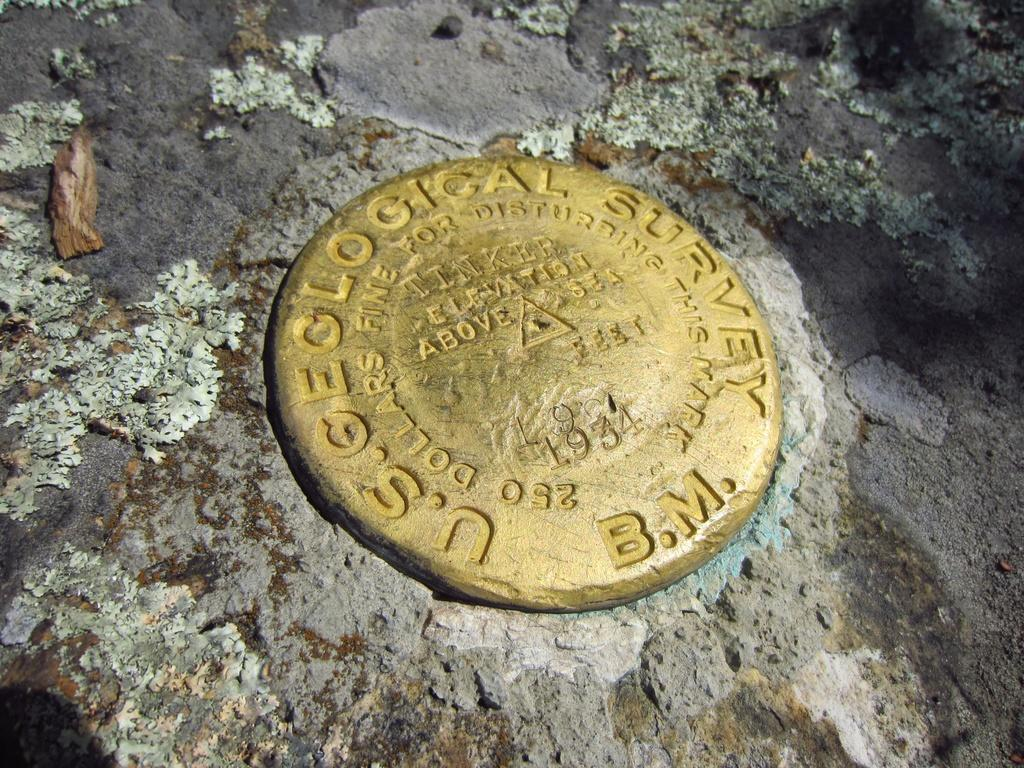<image>
Create a compact narrative representing the image presented. A round disc in gold with US geological survey written around the edge 